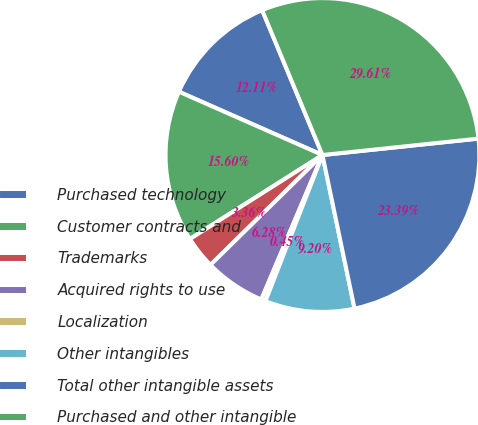<chart> <loc_0><loc_0><loc_500><loc_500><pie_chart><fcel>Purchased technology<fcel>Customer contracts and<fcel>Trademarks<fcel>Acquired rights to use<fcel>Localization<fcel>Other intangibles<fcel>Total other intangible assets<fcel>Purchased and other intangible<nl><fcel>12.11%<fcel>15.6%<fcel>3.36%<fcel>6.28%<fcel>0.45%<fcel>9.2%<fcel>23.39%<fcel>29.61%<nl></chart> 